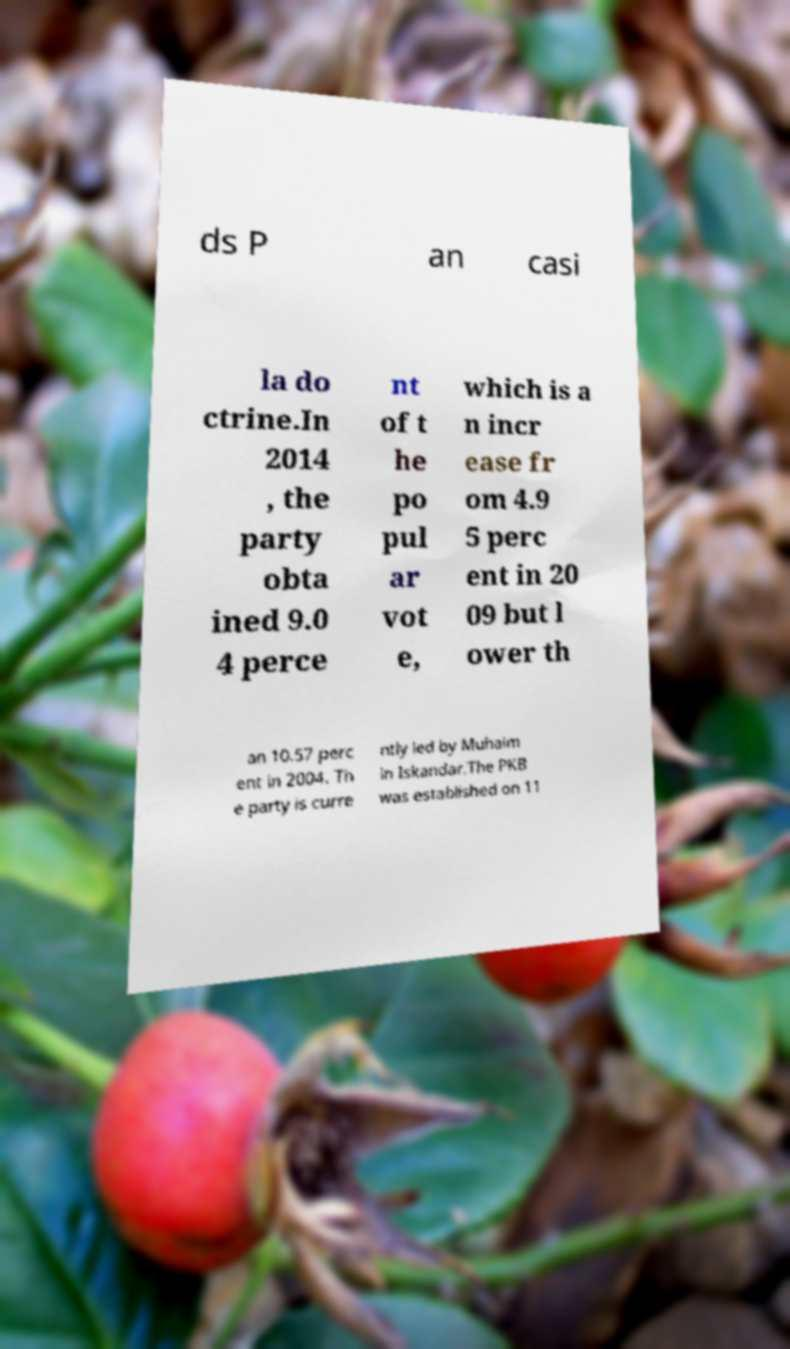Can you read and provide the text displayed in the image?This photo seems to have some interesting text. Can you extract and type it out for me? ds P an casi la do ctrine.In 2014 , the party obta ined 9.0 4 perce nt of t he po pul ar vot e, which is a n incr ease fr om 4.9 5 perc ent in 20 09 but l ower th an 10.57 perc ent in 2004. Th e party is curre ntly led by Muhaim in Iskandar.The PKB was established on 11 